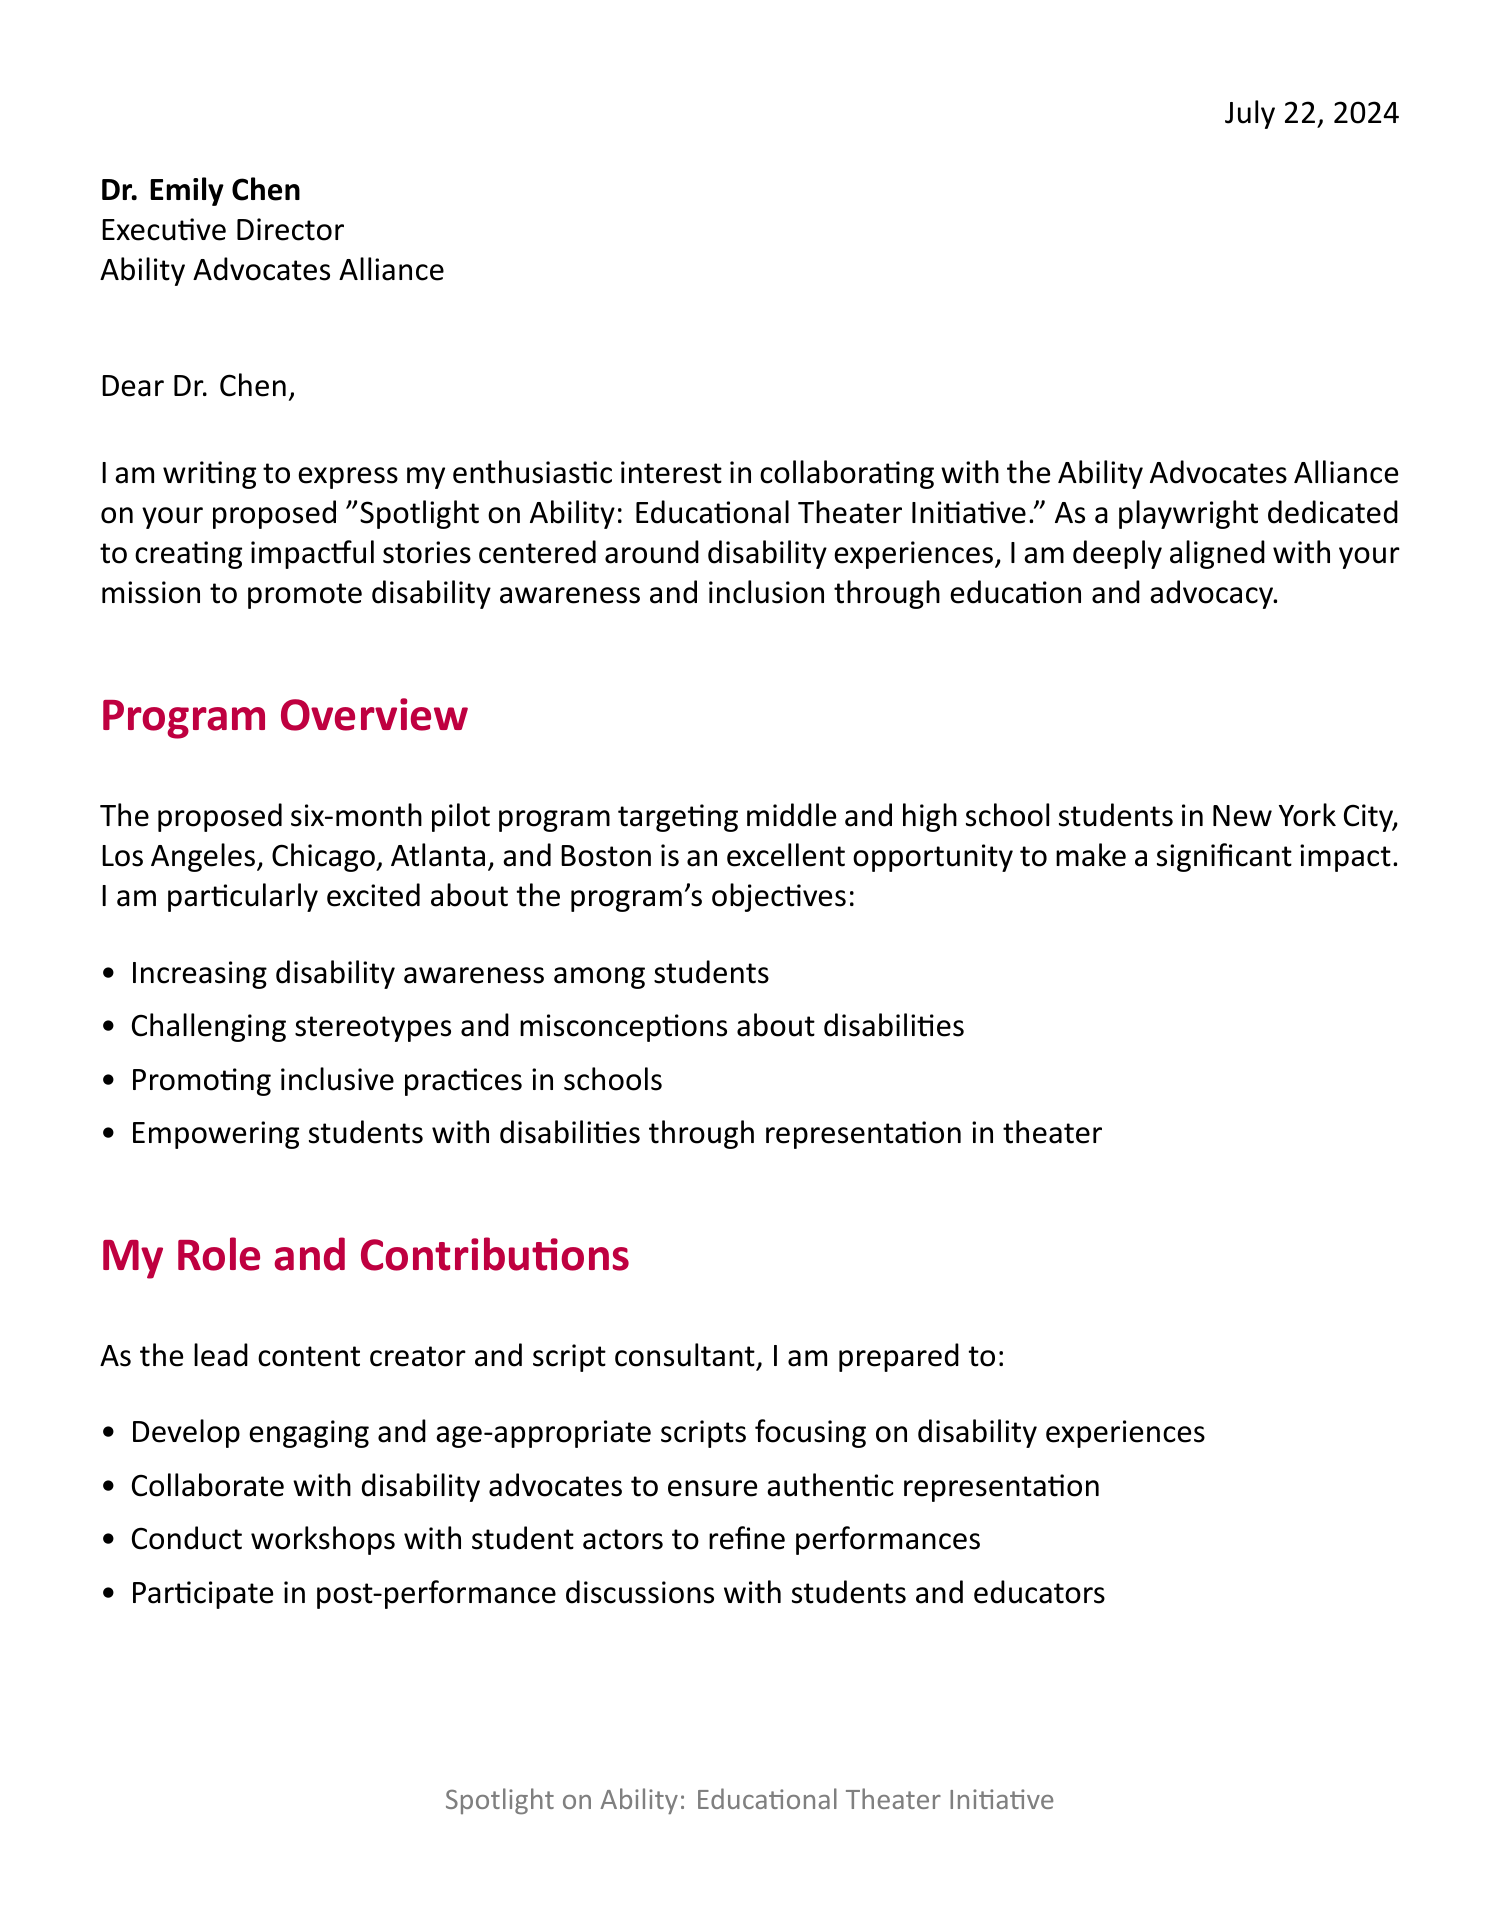What is the name of the advocacy group? The name of the advocacy group is mentioned in the document as Ability Advocates Alliance.
Answer: Ability Advocates Alliance Who is the contact person for the collaboration proposal? The document identifies Dr. Emily Chen as the contact person for this collaboration proposal.
Answer: Dr. Emily Chen What is the target audience for the educational theater program? The target audience for the program is specified in the document as middle and high school students.
Answer: Middle and high school students How long is the proposed pilot program? The duration of the pilot program is indicated in the document as six months.
Answer: 6-month pilot program What are two proposed play themes? The document lists several themes; two examples are "Navigating high school with a physical disability" and "The hidden challenges of invisible disabilities."
Answer: Navigating high school with a physical disability, The hidden challenges of invisible disabilities What is the total estimated cost for the program? The total estimated cost for the program is provided in the document, amounting to $250,000.
Answer: $250,000 What is one expected outcome of the initiative? The document mentions several outcomes; one example is increased empathy and understanding among students.
Answer: Increased empathy and understanding among students What role will the playwright take in the program? The document specifies that the playwright will serve as the lead content creator and script consultant.
Answer: Lead content creator and script consultant What is the name of the speaker who provided a testimonial? The document cites a testimonial from Sarah Thompson, who is a drama teacher at Lincoln High School.
Answer: Sarah Thompson 